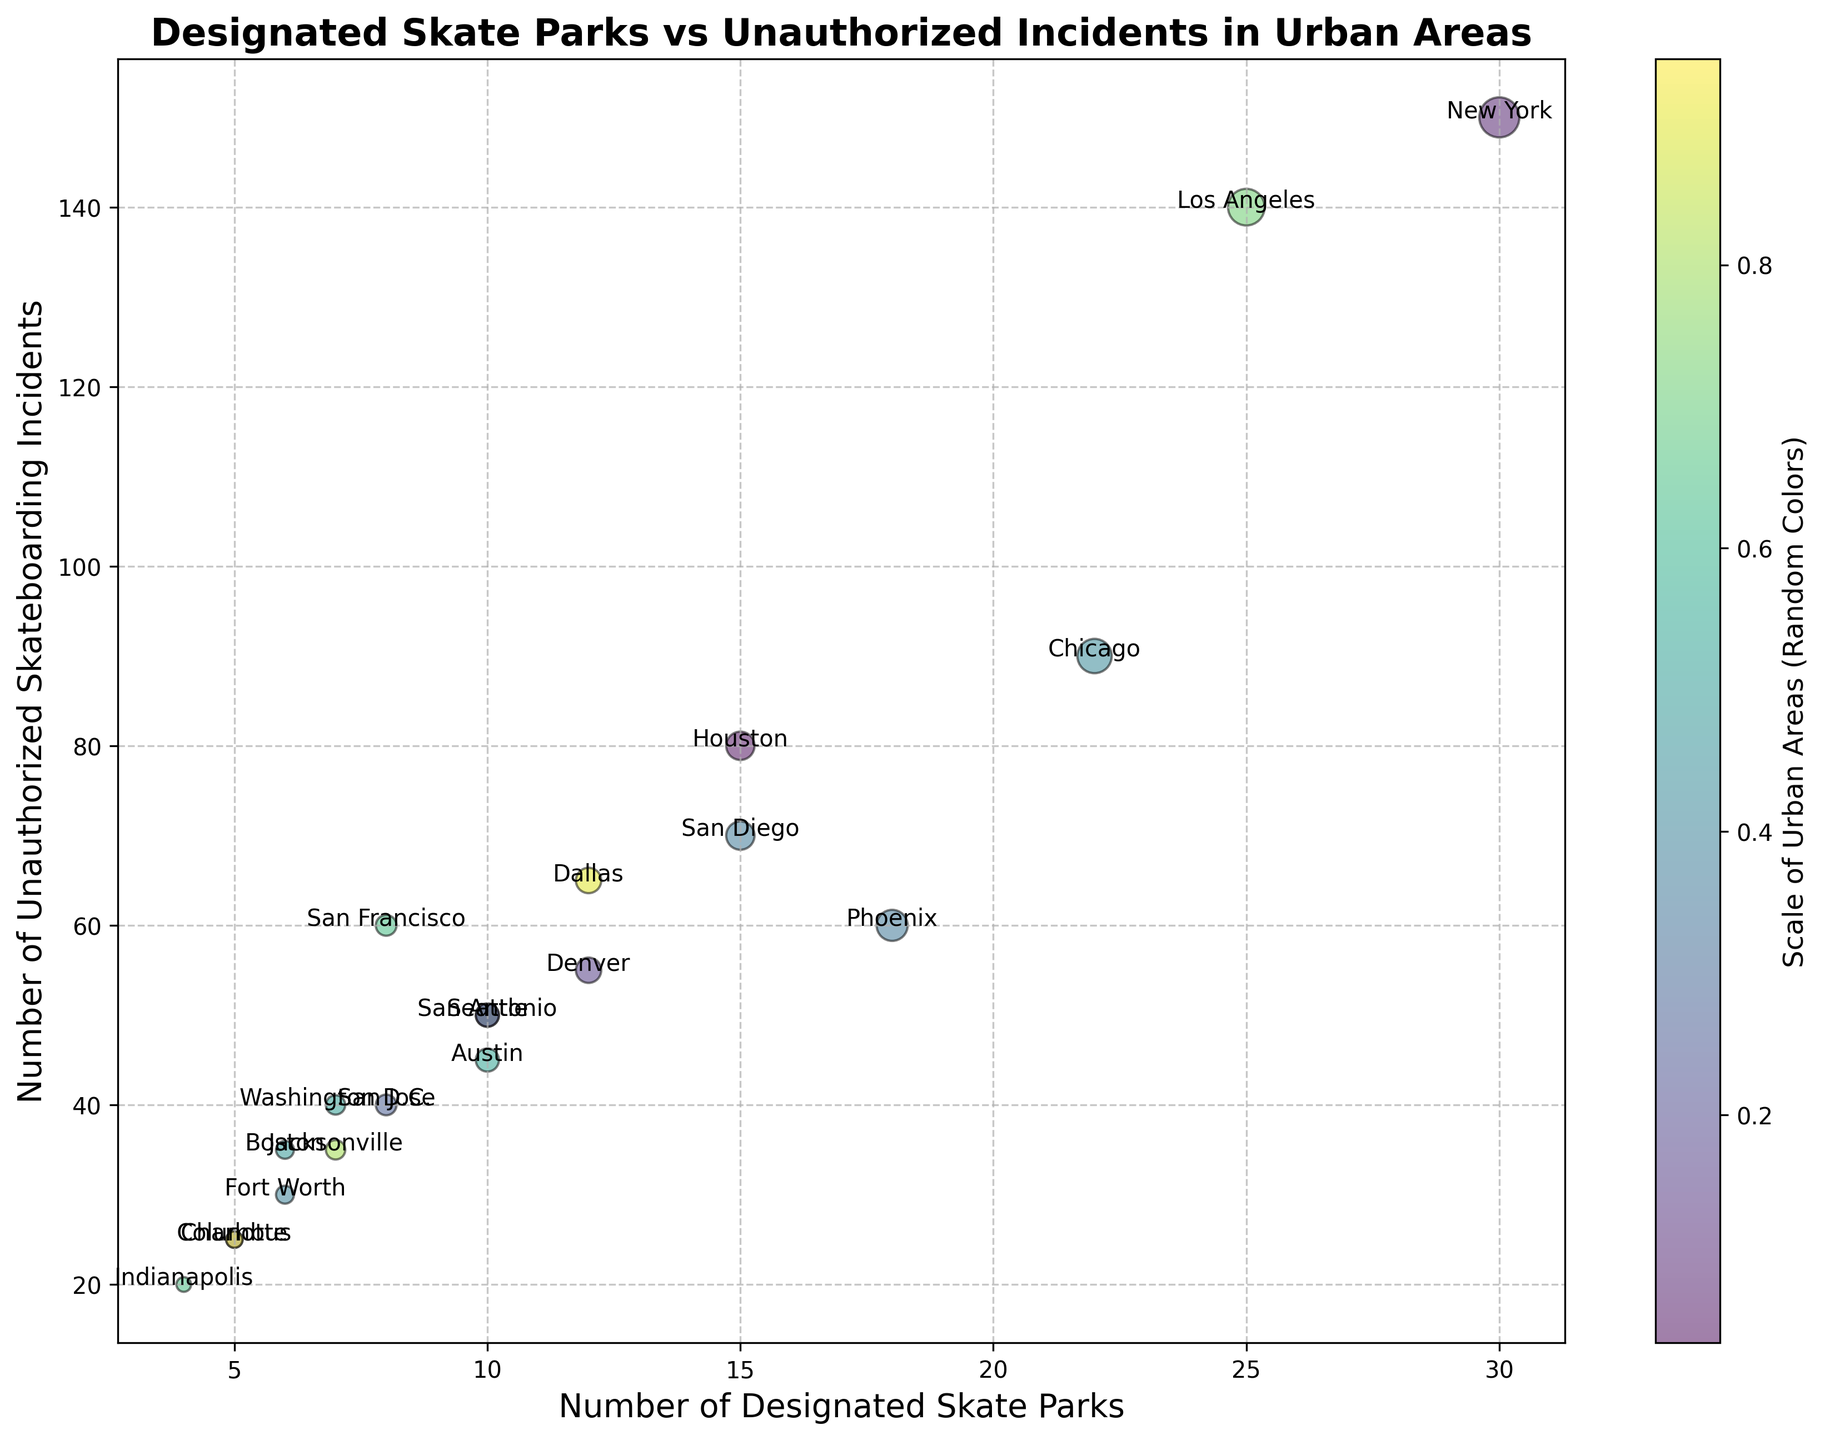Which urban area has the highest number of unauthorized skateboarding incidents? Look at the y-axis values and identify the point with the highest value. New York has the highest number of unauthorized incidents at 150.
Answer: New York Which urban area has the lowest number of designated skate parks? Look at the x-axis values and identify the point with the lowest value. Both Columbus and Charlotte have the lowest number of designated skate parks at 5.
Answer: Columbus and Charlotte Between Los Angeles and San Diego, which has fewer unauthorized incidents? Compare the y-axis values of Los Angeles and San Diego. Los Angeles has 140 unauthorized incidents, while San Diego has 70.
Answer: San Diego What is the combined total of designated skate parks in Houston and Phoenix? Add the x-axis values for Houston (15) and Phoenix (18). The total is 15 + 18 = 33.
Answer: 33 Which urban area has a bigger bubble, indicating a higher number of designated skate parks: Denver or San Francisco? Compare the sizes of the bubbles for Denver and San Francisco. Denver's bubble is larger, indicating it has 12 designated skate parks compared to San Francisco's 8.
Answer: Denver How many more unauthorized incidents are there in Phoenix compared to Fort Worth? Subtract the unauthorized incidents in Fort Worth from those in Phoenix. Phoenix has 60, and Fort Worth has 30, so the difference is 60 - 30 = 30.
Answer: 30 What is the average number of unauthorized skateboarding incidents among New York, Los Angeles, and Chicago? Add the number of incidents and divide by 3. (150 + 140 + 90) / 3 = 380 / 3 ≈ 126.67.
Answer: 126.67 Which urban area has an equal number of designated skate parks and unauthorized incidents? Identify the point where the x-axis value and y-axis value are the same. Jacksonville has 7 designated skate parks and 35 unauthorized incidents.
Answer: Jacksonville If a city has 10 designated skate parks, what is the range of unauthorized incidents observed? Look for the y-axis values corresponding to x-axis values of 10. San Antonio has 50 incidents, Austin has 45, Seattle has 50, and Boston has 35. The range is 50 - 35 = 15.
Answer: 15 